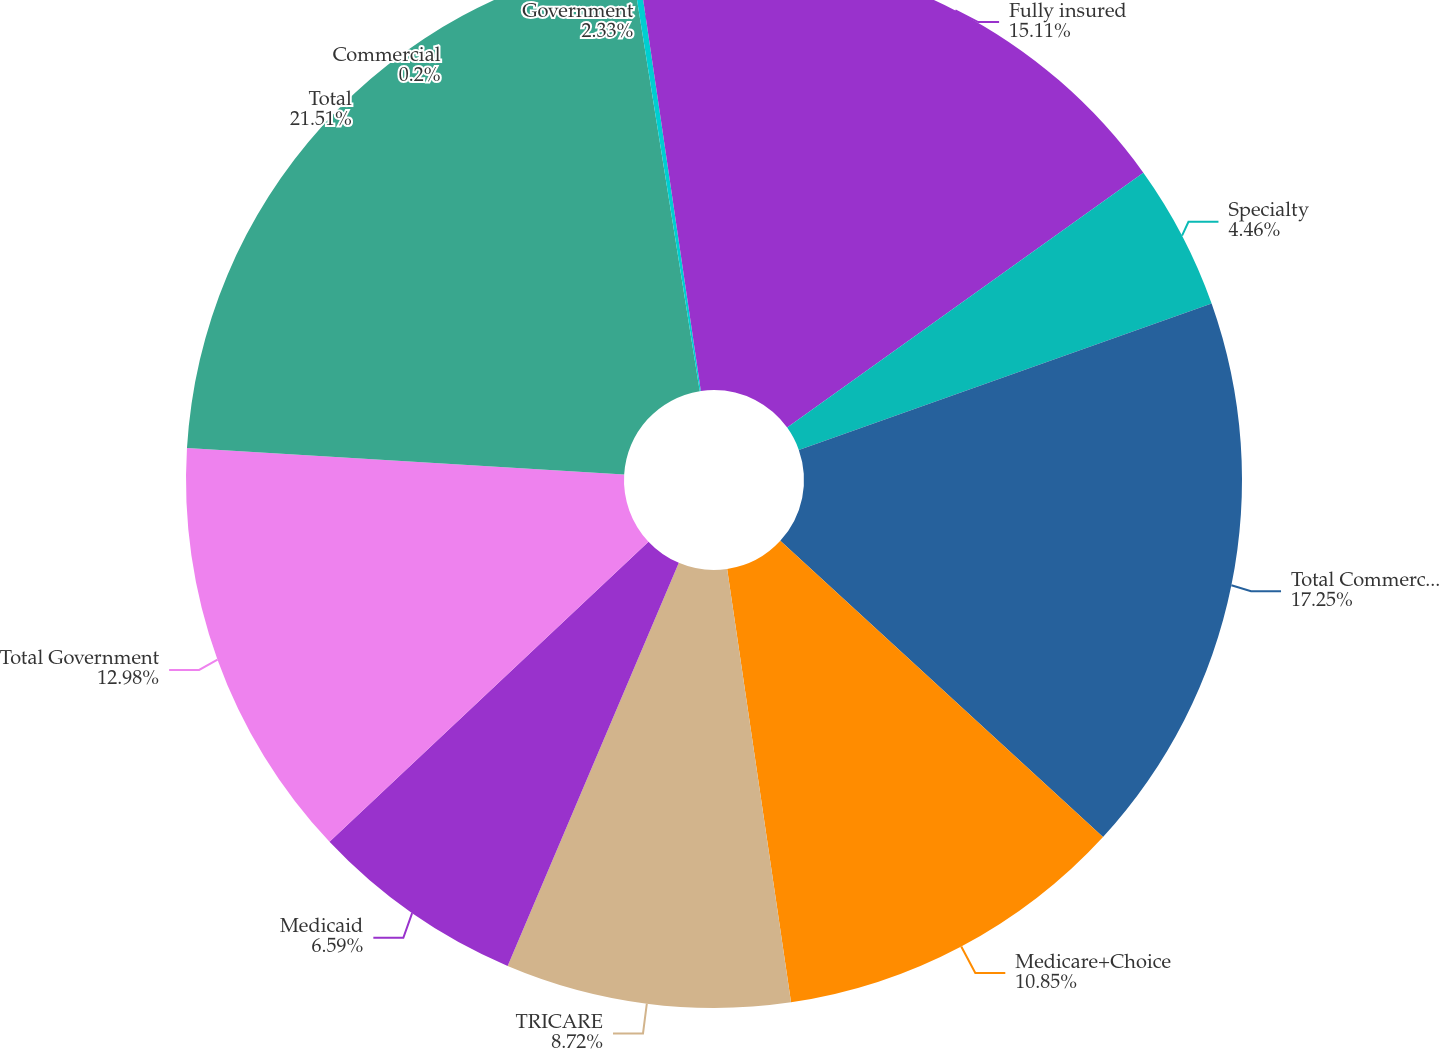<chart> <loc_0><loc_0><loc_500><loc_500><pie_chart><fcel>Fully insured<fcel>Specialty<fcel>Total Commercial<fcel>Medicare+Choice<fcel>TRICARE<fcel>Medicaid<fcel>Total Government<fcel>Total<fcel>Commercial<fcel>Government<nl><fcel>15.11%<fcel>4.46%<fcel>17.24%<fcel>10.85%<fcel>8.72%<fcel>6.59%<fcel>12.98%<fcel>21.5%<fcel>0.2%<fcel>2.33%<nl></chart> 